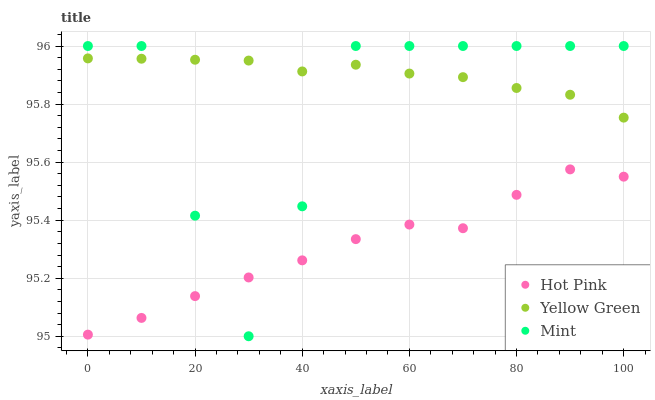Does Hot Pink have the minimum area under the curve?
Answer yes or no. Yes. Does Yellow Green have the maximum area under the curve?
Answer yes or no. Yes. Does Mint have the minimum area under the curve?
Answer yes or no. No. Does Mint have the maximum area under the curve?
Answer yes or no. No. Is Yellow Green the smoothest?
Answer yes or no. Yes. Is Mint the roughest?
Answer yes or no. Yes. Is Mint the smoothest?
Answer yes or no. No. Is Yellow Green the roughest?
Answer yes or no. No. Does Mint have the lowest value?
Answer yes or no. Yes. Does Yellow Green have the lowest value?
Answer yes or no. No. Does Mint have the highest value?
Answer yes or no. Yes. Does Yellow Green have the highest value?
Answer yes or no. No. Is Hot Pink less than Yellow Green?
Answer yes or no. Yes. Is Yellow Green greater than Hot Pink?
Answer yes or no. Yes. Does Mint intersect Yellow Green?
Answer yes or no. Yes. Is Mint less than Yellow Green?
Answer yes or no. No. Is Mint greater than Yellow Green?
Answer yes or no. No. Does Hot Pink intersect Yellow Green?
Answer yes or no. No. 